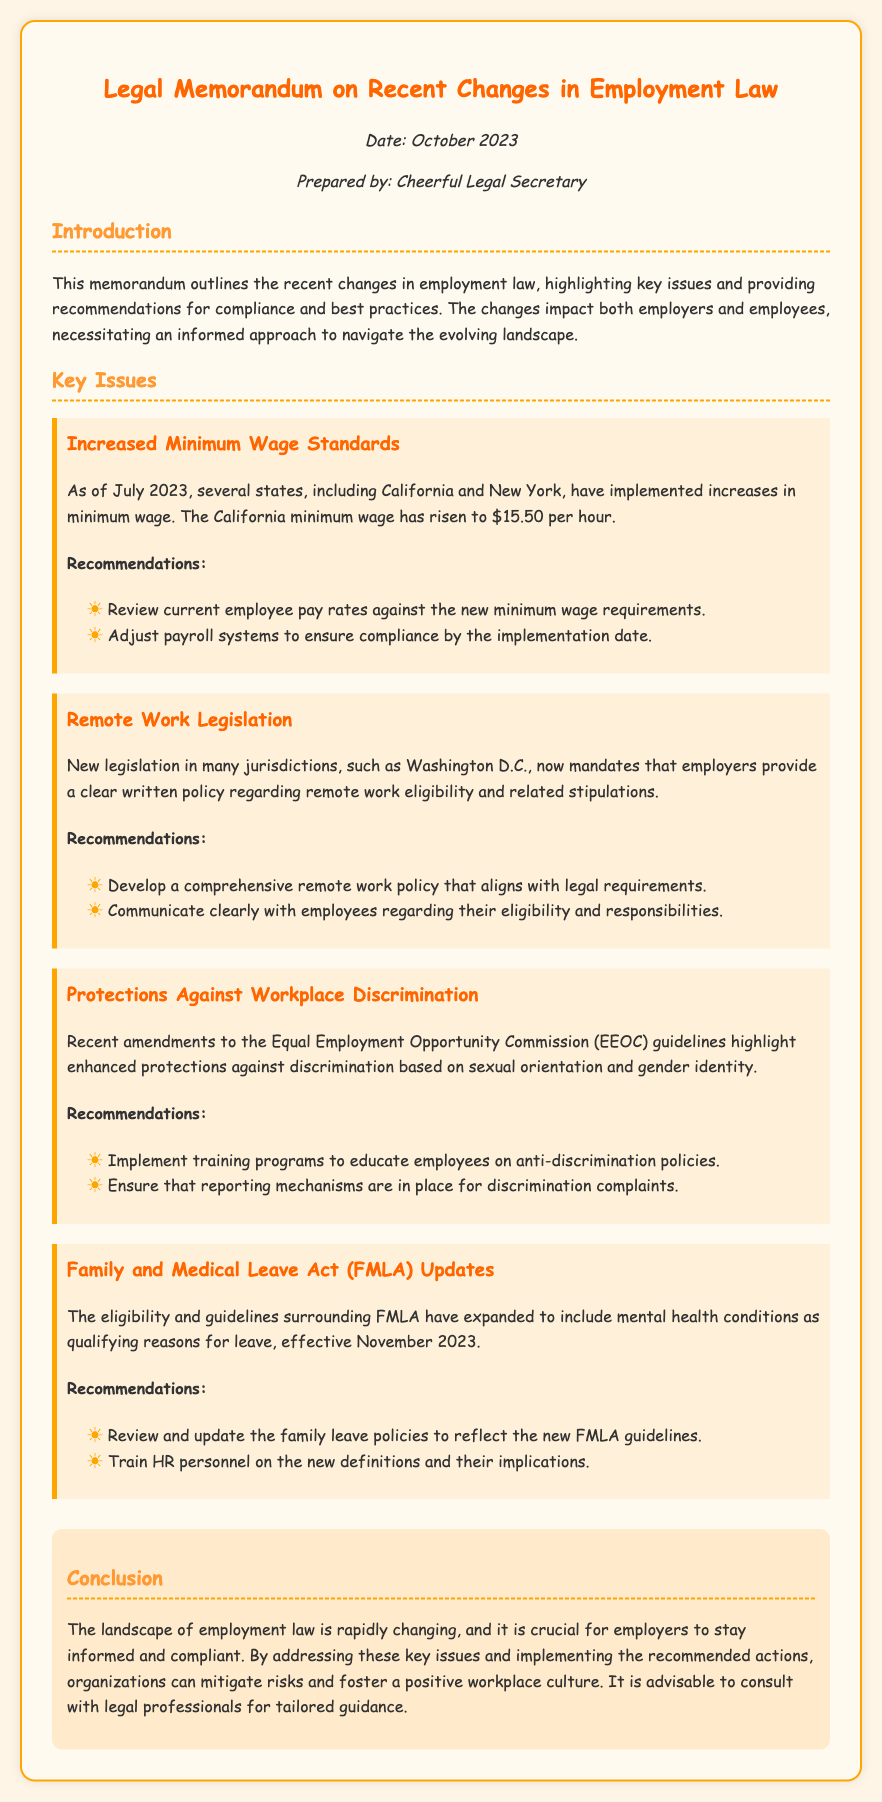What is the date of the memorandum? The date of the memorandum is mentioned in the meta section.
Answer: October 2023 What is the minimum wage in California as of July 2023? The minimum wage in California is listed under the key issues section.
Answer: $15.50 per hour Which legislation requires a written policy for remote work? The legislation mandating a policy for remote work is addressed in the second key issue.
Answer: Washington D.C What new reason has been added to the FMLA guidelines for leave? The new reason for leave under FMLA is detailed in the fourth key issue.
Answer: Mental health conditions What is the purpose of implementing training programs mentioned in the recommendations? The training programs are intended as a part of the anti-discrimination policies discussed in the third key issue.
Answer: Educate employees How many key issues are outlined in the memorandum? The number of key issues can be counted in the relevant section of the document.
Answer: Four 